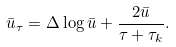<formula> <loc_0><loc_0><loc_500><loc_500>\bar { u } _ { \tau } = \Delta \log \bar { u } + \frac { 2 \bar { u } } { \tau + \tau _ { k } } .</formula> 